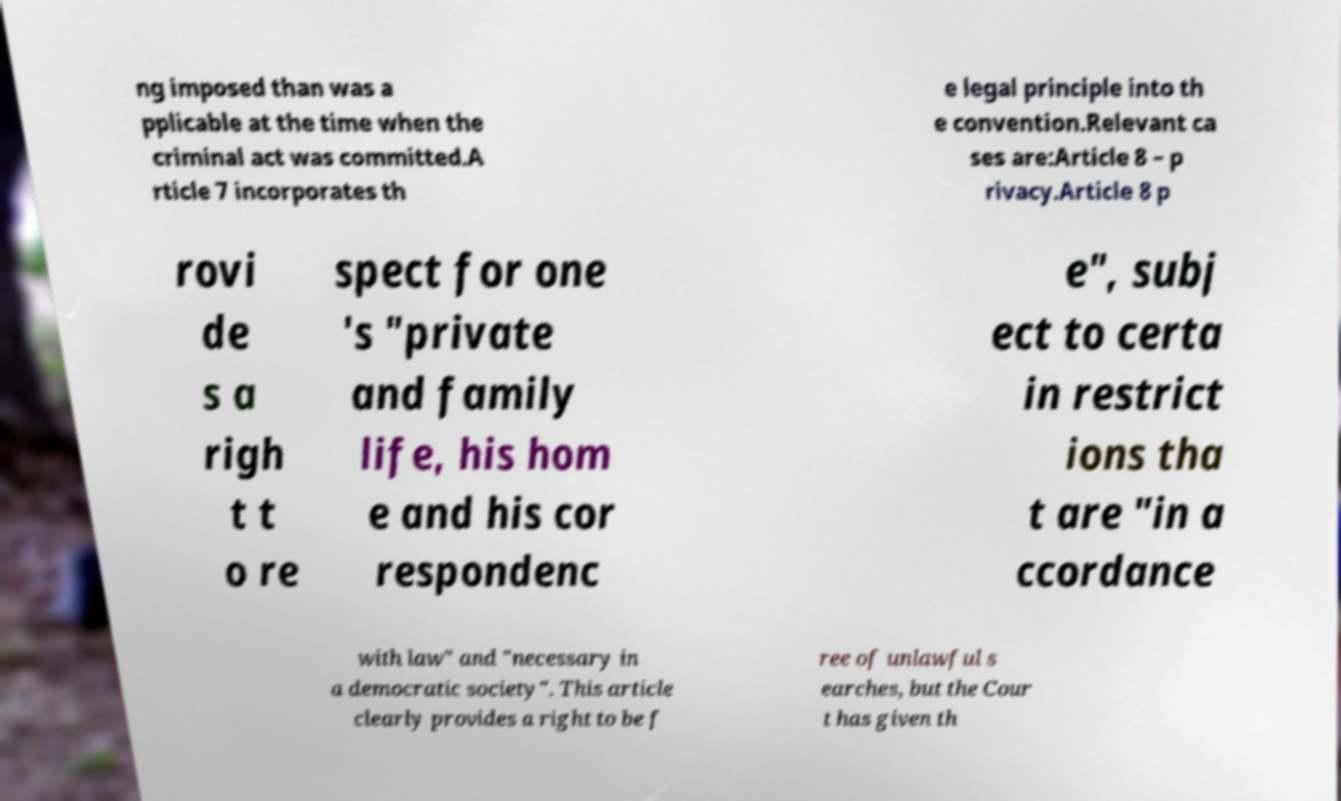Can you accurately transcribe the text from the provided image for me? ng imposed than was a pplicable at the time when the criminal act was committed.A rticle 7 incorporates th e legal principle into th e convention.Relevant ca ses are:Article 8 – p rivacy.Article 8 p rovi de s a righ t t o re spect for one 's "private and family life, his hom e and his cor respondenc e", subj ect to certa in restrict ions tha t are "in a ccordance with law" and "necessary in a democratic society". This article clearly provides a right to be f ree of unlawful s earches, but the Cour t has given th 